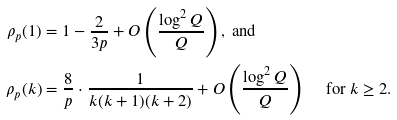<formula> <loc_0><loc_0><loc_500><loc_500>\rho _ { p } ( 1 ) & = 1 - \frac { 2 } { 3 p } + O \left ( \frac { \log ^ { 2 } Q } { Q } \right ) , \text { and } \\ \rho _ { p } ( k ) & = \frac { 8 } { p } \cdot \frac { 1 } { k ( k + 1 ) ( k + 2 ) } + O \left ( \frac { \log ^ { 2 } Q } { Q } \right ) \quad \text { for } k \geq 2 .</formula> 